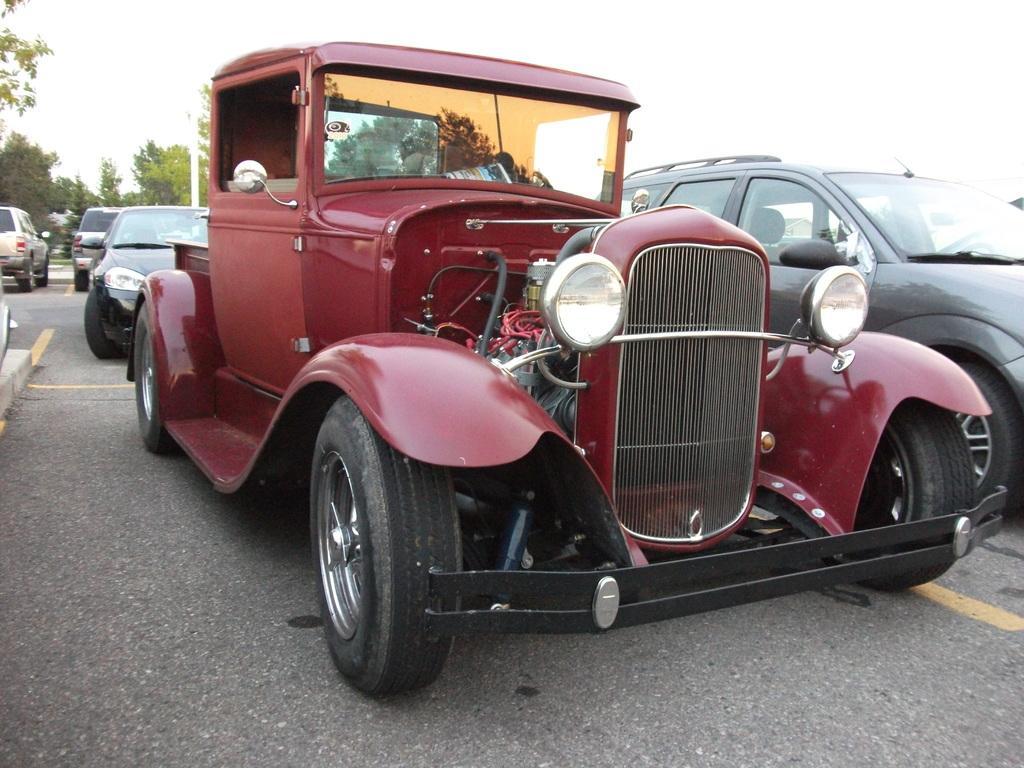In one or two sentences, can you explain what this image depicts? In this image we can see vehicles on the road. In the background we can see trees, pole, and sky. 